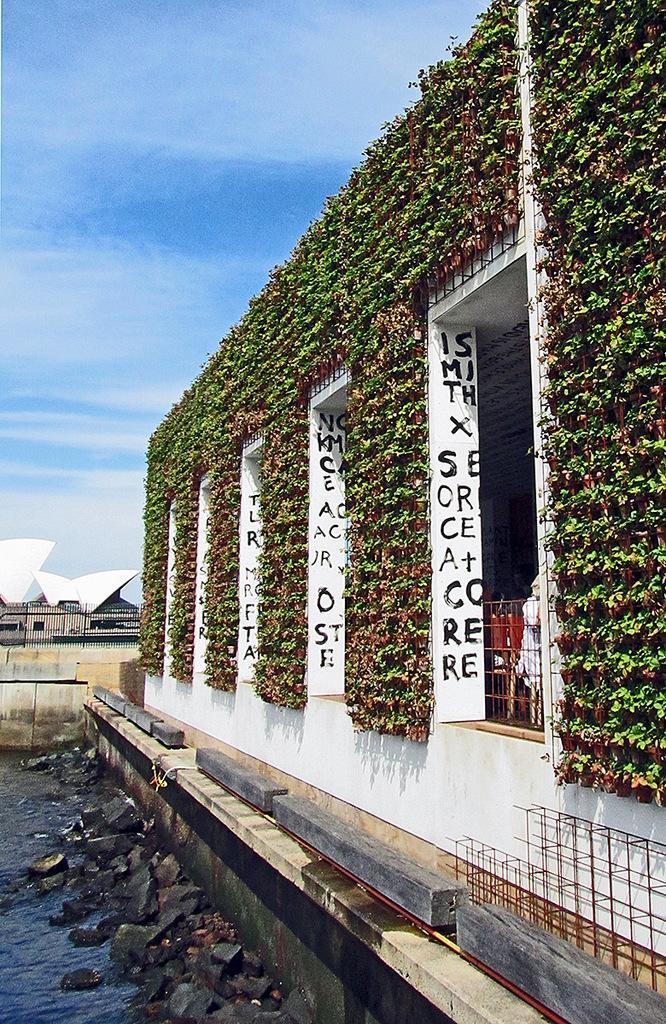In one or two sentences, can you explain what this image depicts? In this picture we can see stones, water, house plants, buildings, railings, walls, rods and some objects and in the background we can see the sky. 